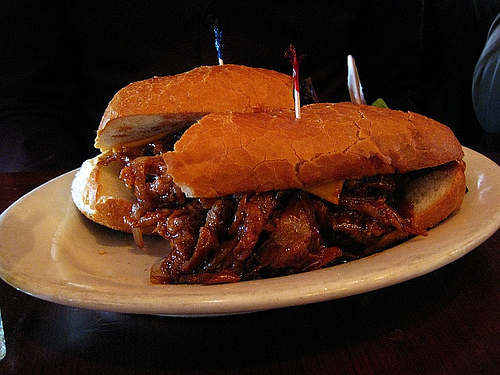<image>What vegetable is sticking out of the burger? I am not sure which vegetable is sticking out of the burger. It could either be onions, spinach or none. What vegetable is sticking out of the burger? I am not sure what vegetable is sticking out of the burger. It can be onions or spinach. 